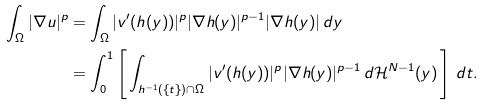<formula> <loc_0><loc_0><loc_500><loc_500>\int _ { \Omega } | \nabla u | ^ { p } & = \int _ { \Omega } | v ^ { \prime } ( h ( y ) ) | ^ { p } | \nabla h ( y ) | ^ { p - 1 } | \nabla h ( y ) | \, d y \\ & = \int _ { 0 } ^ { 1 } \left [ \, \int _ { h ^ { - 1 } ( \{ t \} ) \cap \Omega } | v ^ { \prime } ( h ( y ) ) | ^ { p } | \nabla h ( y ) | ^ { p - 1 } \, d \mathcal { H } ^ { N - 1 } ( y ) \, \right ] \, d t .</formula> 